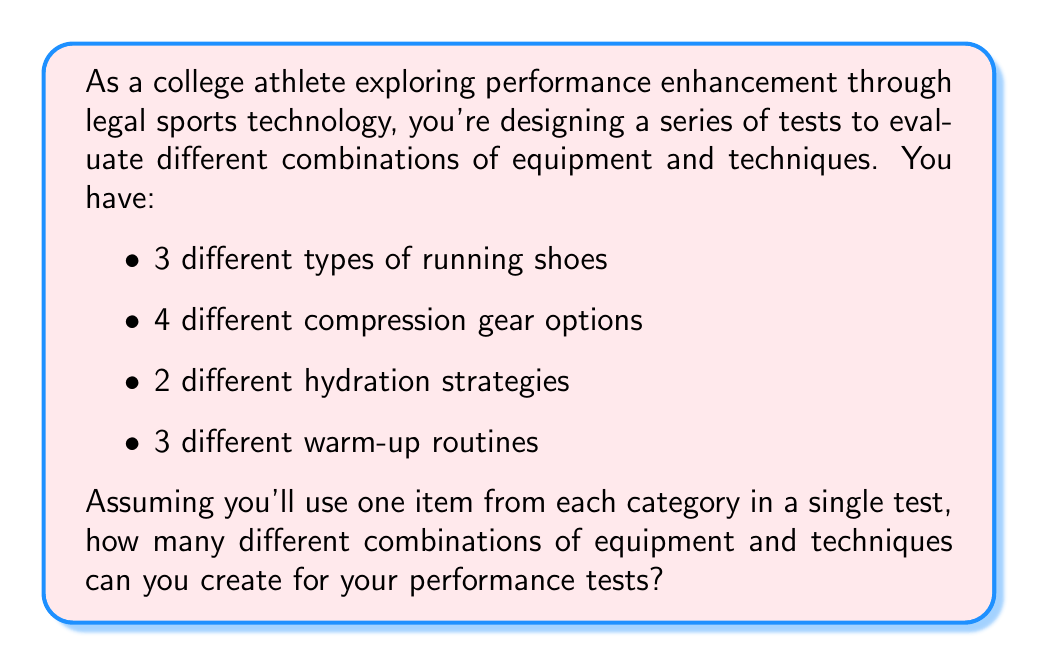Show me your answer to this math problem. To solve this problem, we'll use the multiplication principle of counting. This principle states that if we have a sequence of choices, and the number of options for each choice is independent of the others, then the total number of possible outcomes is the product of the number of options for each choice.

Let's break down the problem:

1. Running shoes: 3 options
2. Compression gear: 4 options
3. Hydration strategies: 2 options
4. Warm-up routines: 3 options

For each test, you'll choose one option from each category. The choices are independent, meaning the selection of one doesn't affect the others.

Therefore, we can calculate the total number of combinations as follows:

$$ \text{Total combinations} = 3 \times 4 \times 2 \times 3 $$

Let's compute this:

$$ \begin{aligned}
\text{Total combinations} &= 3 \times 4 \times 2 \times 3 \\
&= 12 \times 2 \times 3 \\
&= 24 \times 3 \\
&= 72
\end{aligned} $$

This means you can create 72 different combinations of equipment and techniques for your performance tests.
Answer: 72 combinations 